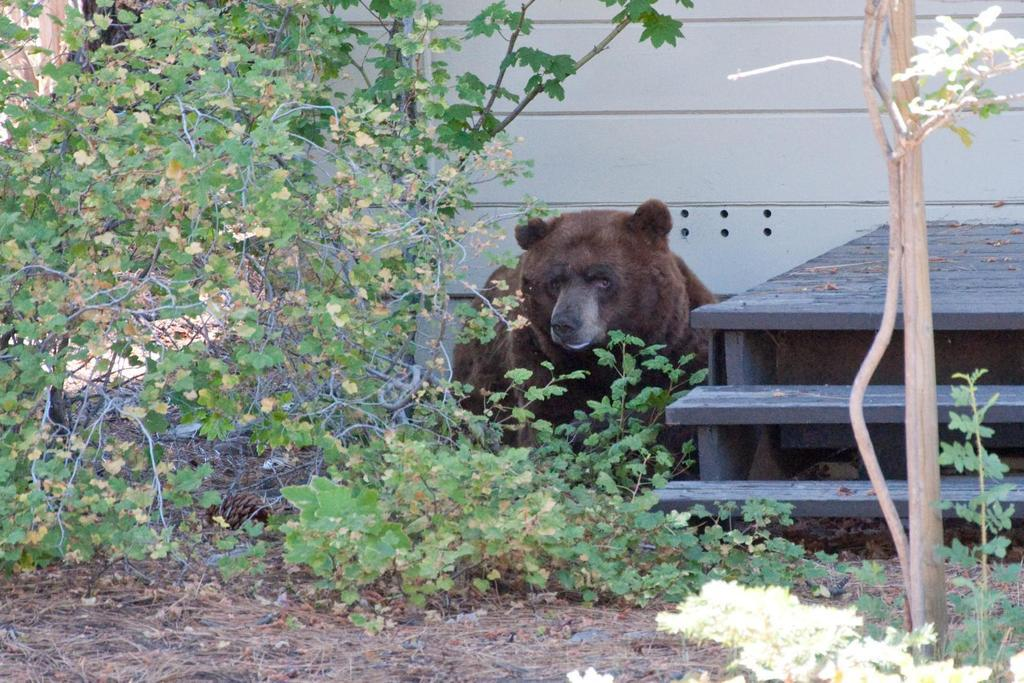What type of animal can be seen in the image? There is an animal in the image, but its specific type cannot be determined from the provided facts. Where is the animal located in relation to the wall? The animal is near a wall in the image. What type of seating is present in the image? There is a bench in the image. On which side of the image is the bench located? The bench is towards the right side of the image. What type of vegetation is present in the image? There are plants in the image. Where are the plants located in relation to the bench? The plants are near the bench in the image. What type of surface is visible in the image? There is a ground visible in the image. What type of skin condition is visible on the animal in the image? There is no information about the animal's skin condition in the image, and therefore it cannot be determined. 